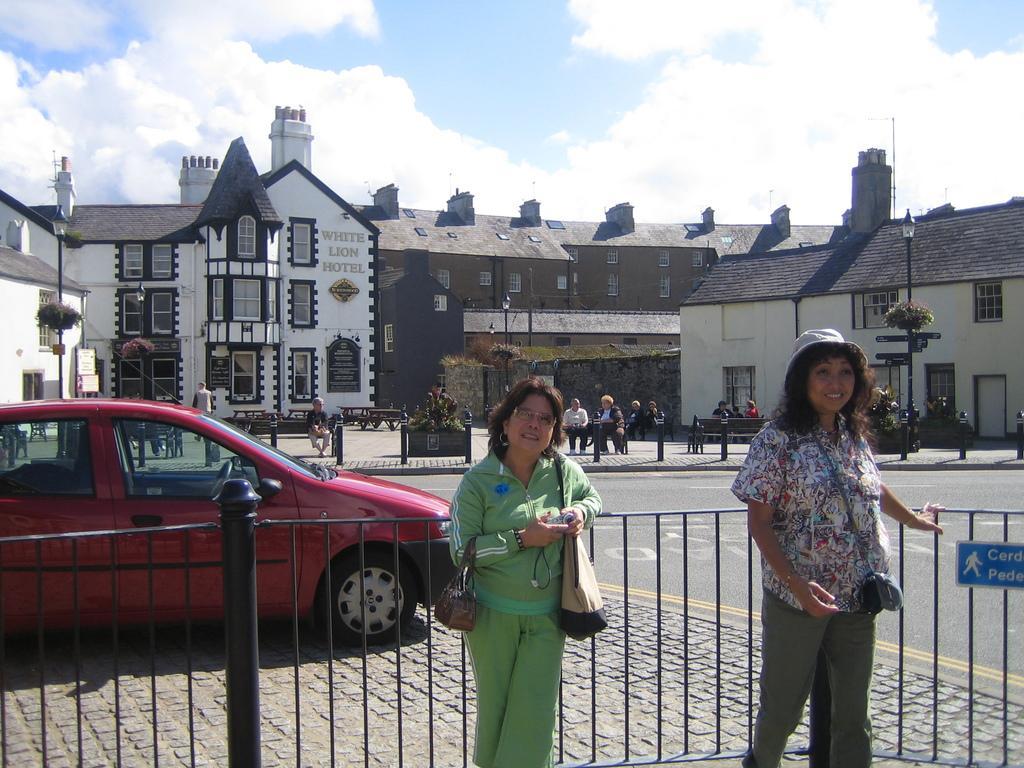Can you describe this image briefly? In this picture I can observe two women standing in front of the railing in the middle of the picture. On the left side I can observe a car moving on the road. In the background there is a building and some clouds in the sky. 